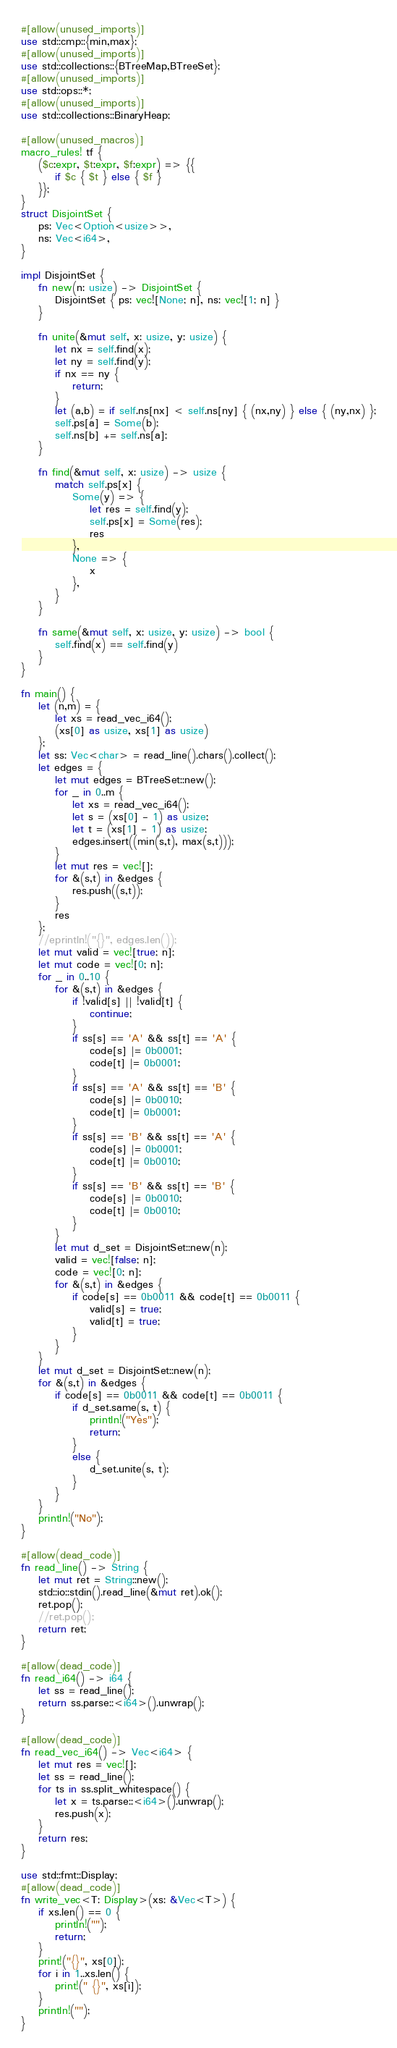<code> <loc_0><loc_0><loc_500><loc_500><_Rust_>#[allow(unused_imports)]
use std::cmp::{min,max};
#[allow(unused_imports)]
use std::collections::{BTreeMap,BTreeSet};
#[allow(unused_imports)]
use std::ops::*;
#[allow(unused_imports)]
use std::collections::BinaryHeap;

#[allow(unused_macros)]
macro_rules! tf {
    ($c:expr, $t:expr, $f:expr) => {{
        if $c { $t } else { $f }
    }};
}
struct DisjointSet {
    ps: Vec<Option<usize>>,
    ns: Vec<i64>,
}

impl DisjointSet {
    fn new(n: usize) -> DisjointSet {
        DisjointSet { ps: vec![None; n], ns: vec![1; n] }
    }

    fn unite(&mut self, x: usize, y: usize) {
        let nx = self.find(x);
        let ny = self.find(y);
        if nx == ny {
            return;
        }
        let (a,b) = if self.ns[nx] < self.ns[ny] { (nx,ny) } else { (ny,nx) };
        self.ps[a] = Some(b);
        self.ns[b] += self.ns[a];
    }

    fn find(&mut self, x: usize) -> usize {
        match self.ps[x] {
            Some(y) => {
                let res = self.find(y);
                self.ps[x] = Some(res);
                res
            },
            None => {
                x
            },
        }
    }

    fn same(&mut self, x: usize, y: usize) -> bool {
        self.find(x) == self.find(y)
    }
}

fn main() {
    let (n,m) = {
        let xs = read_vec_i64();
        (xs[0] as usize, xs[1] as usize)
    };
    let ss: Vec<char> = read_line().chars().collect();
    let edges = {
        let mut edges = BTreeSet::new();
        for _ in 0..m {
            let xs = read_vec_i64();
            let s = (xs[0] - 1) as usize;
            let t = (xs[1] - 1) as usize;
            edges.insert((min(s,t), max(s,t)));
        }
        let mut res = vec![];
        for &(s,t) in &edges {
            res.push((s,t));
        }
        res
    };
    //eprintln!("{}", edges.len());
    let mut valid = vec![true; n];
    let mut code = vec![0; n];
    for _ in 0..10 {
        for &(s,t) in &edges {
            if !valid[s] || !valid[t] {
                continue;
            }
            if ss[s] == 'A' && ss[t] == 'A' {
                code[s] |= 0b0001;
                code[t] |= 0b0001;
            }
            if ss[s] == 'A' && ss[t] == 'B' {
                code[s] |= 0b0010;
                code[t] |= 0b0001;
            }
            if ss[s] == 'B' && ss[t] == 'A' {
                code[s] |= 0b0001;
                code[t] |= 0b0010;
            }
            if ss[s] == 'B' && ss[t] == 'B' {
                code[s] |= 0b0010;
                code[t] |= 0b0010;
            }
        }
        let mut d_set = DisjointSet::new(n);
        valid = vec![false; n];
        code = vec![0; n];
        for &(s,t) in &edges {
            if code[s] == 0b0011 && code[t] == 0b0011 {
                valid[s] = true;
                valid[t] = true;
            }
        }
    }
    let mut d_set = DisjointSet::new(n);
    for &(s,t) in &edges {
        if code[s] == 0b0011 && code[t] == 0b0011 {
            if d_set.same(s, t) {
                println!("Yes");
                return;
            }
            else {
                d_set.unite(s, t);
            }
        }
    }
    println!("No");
}

#[allow(dead_code)]
fn read_line() -> String {
    let mut ret = String::new();
    std::io::stdin().read_line(&mut ret).ok();
    ret.pop();
    //ret.pop();
    return ret;
}

#[allow(dead_code)]
fn read_i64() -> i64 {
    let ss = read_line();
    return ss.parse::<i64>().unwrap();
}

#[allow(dead_code)]
fn read_vec_i64() -> Vec<i64> {
    let mut res = vec![];
    let ss = read_line();
    for ts in ss.split_whitespace() {
        let x = ts.parse::<i64>().unwrap();
        res.push(x);
    }
    return res;
}

use std::fmt::Display;
#[allow(dead_code)]
fn write_vec<T: Display>(xs: &Vec<T>) {
    if xs.len() == 0 {
        println!("");
        return;
    }
    print!("{}", xs[0]);
    for i in 1..xs.len() {
        print!(" {}", xs[i]);
    }
    println!("");
}
</code> 